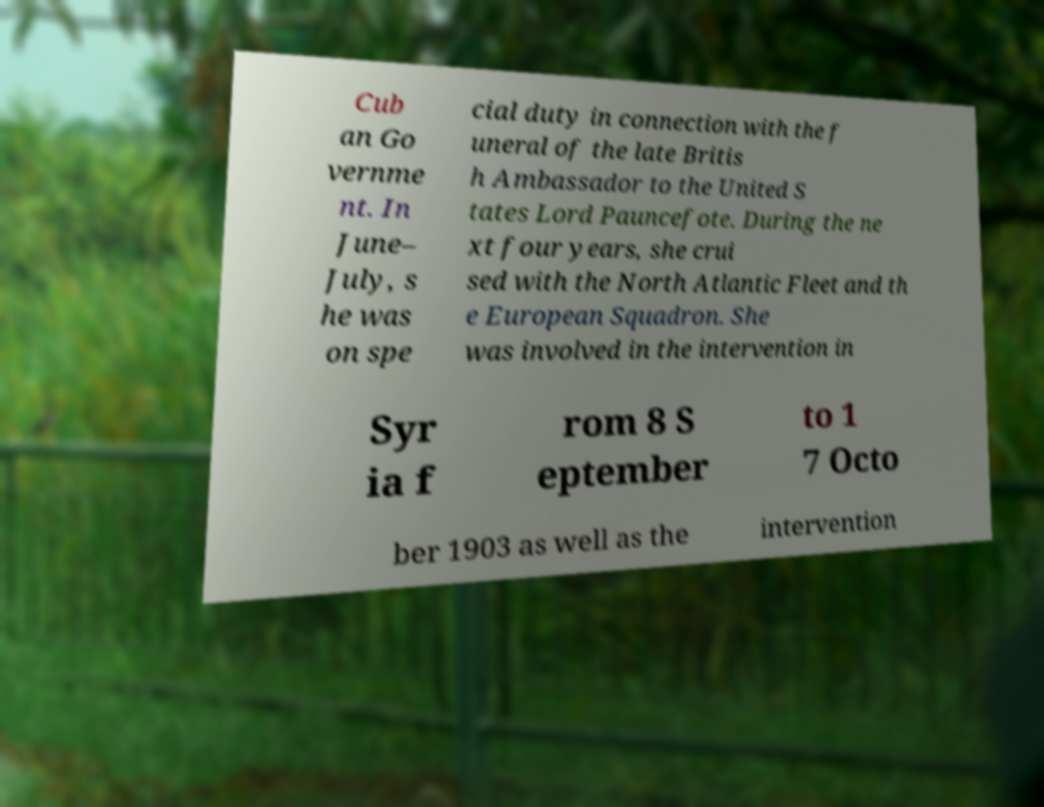I need the written content from this picture converted into text. Can you do that? Cub an Go vernme nt. In June– July, s he was on spe cial duty in connection with the f uneral of the late Britis h Ambassador to the United S tates Lord Pauncefote. During the ne xt four years, she crui sed with the North Atlantic Fleet and th e European Squadron. She was involved in the intervention in Syr ia f rom 8 S eptember to 1 7 Octo ber 1903 as well as the intervention 